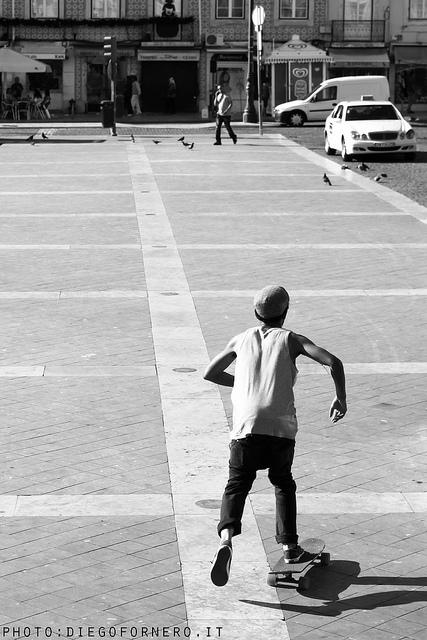What kind of refined natural resource is used to power the white car? Please explain your reasoning. gasoline. This is an automobile 